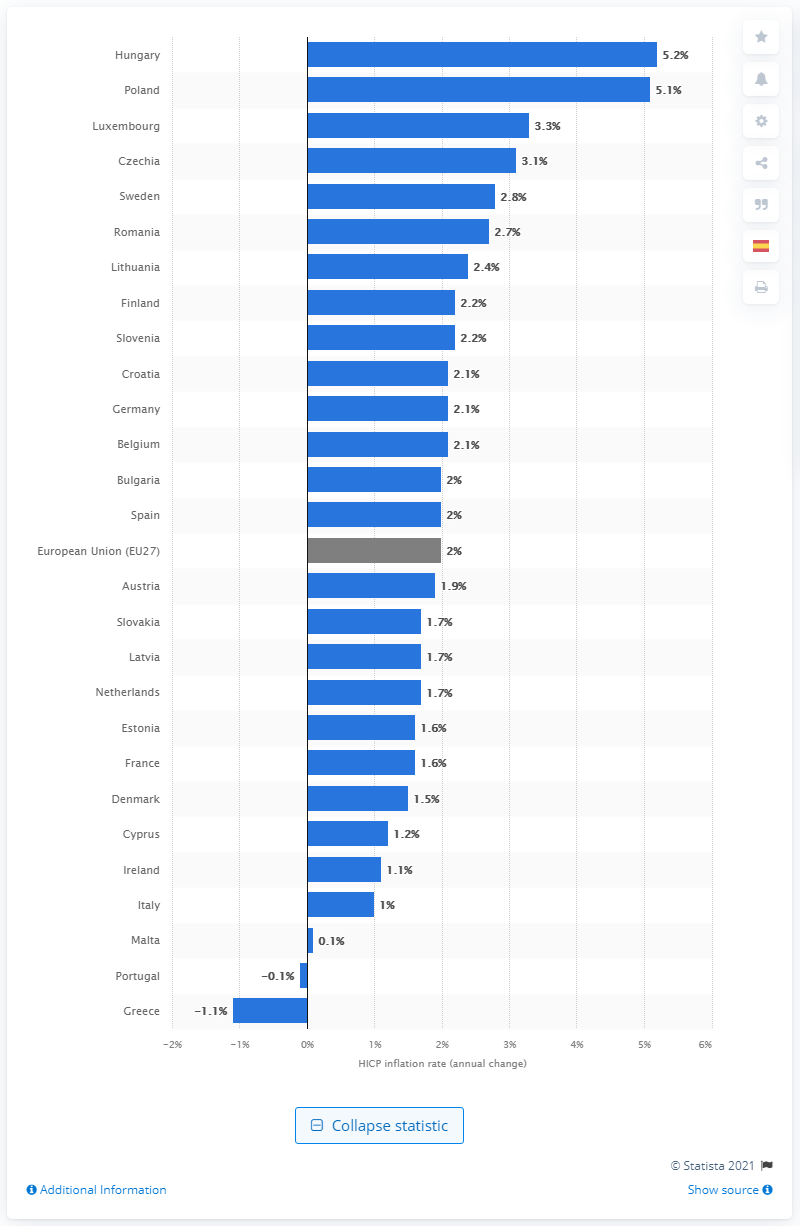Outline some significant characteristics in this image. According to the available data, the inflation rate in Hungary in April 2021 was 5.2%. The inflation rate in Greece in April 2021 was 1.1%. 